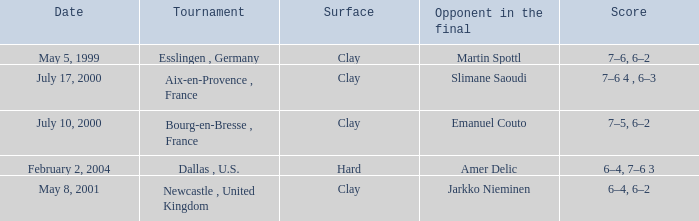What is the Opponent in the final of the game on february 2, 2004? Amer Delic. 